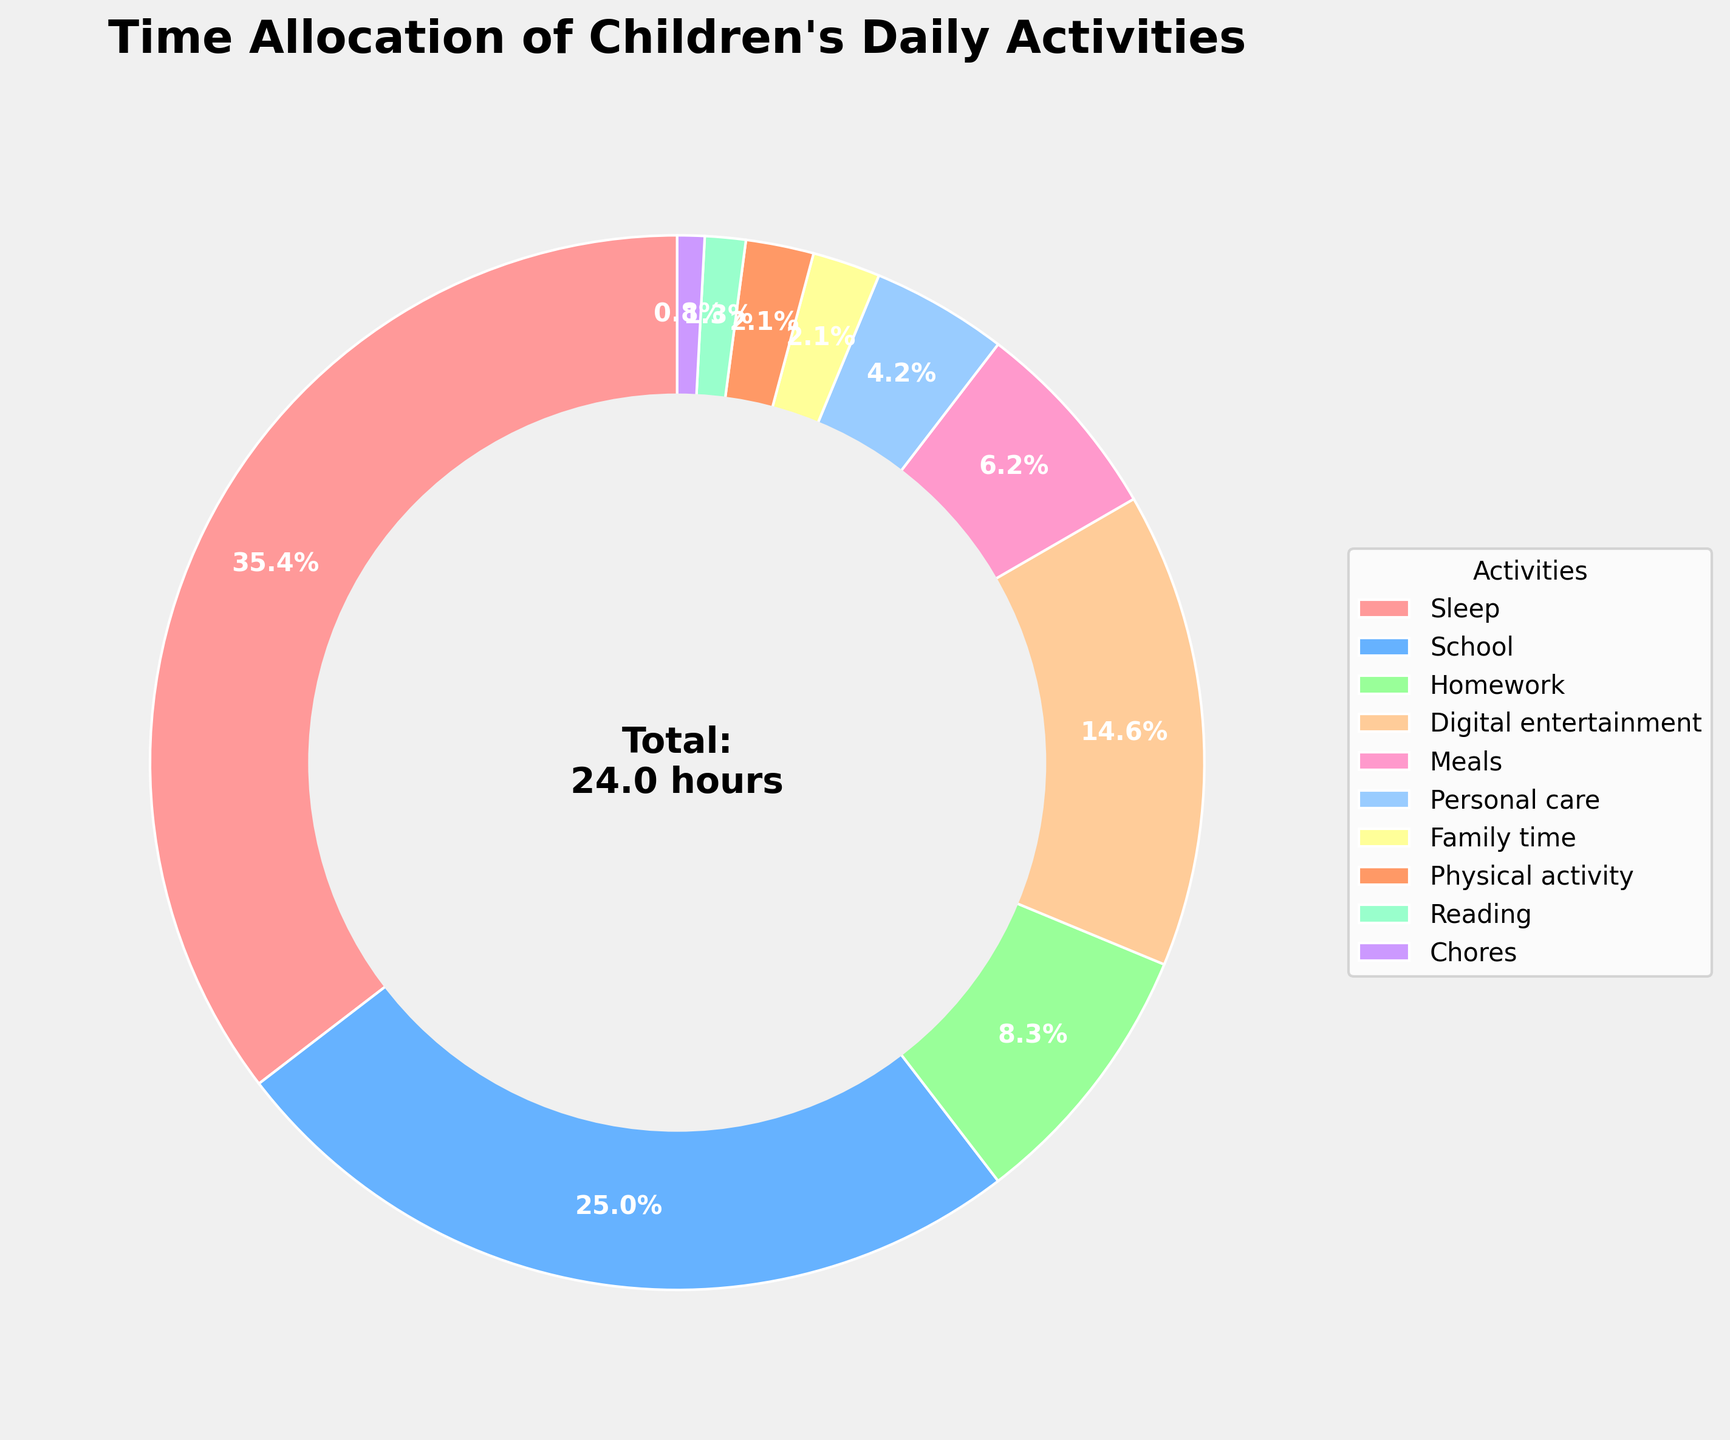How much time is spent on digital entertainment compared to school? Digital entertainment takes up 3.5 hours, and school takes 6 hours. Therefore, digital entertainment is 6 - 3.5 = 2.5 hours less than school.
Answer: 2.5 hours less Which two activities together make up the least amount of time spent? Chores and reading have the smallest amounts of time with 0.2 and 0.3 hours respectively. Their sum is 0.2 + 0.3 = 0.5 hours, which is less than any other combination.
Answer: Chores and Reading What percentage of the day is spent on sleep and school combined? Sleep takes up 8.5 hours and school takes 6 hours. Together, they make up 8.5 + 6 = 14.5 hours. The entire day totals 24 hours. Therefore, the percentage is (14.5/24) * 100 ≈ 60.4%.
Answer: 60.4% Which activity is allocated half an hour? The figure's visual cues show that family time and physical activity are both represented by half an hour since they are labeled as 0.5 hours.
Answer: Family time and Physical activity What is the difference in time spent between meals and personal care? Meals take up 1.5 hours, and personal care takes 1 hour. The difference is 1.5 - 1 = 0.5 hours.
Answer: 0.5 hours How much more time is allocated to digital entertainment than to reading? Reading gets 0.3 hours, while digital entertainment gets 3.5 hours. Therefore, digital entertainment gets 3.5 - 0.3 = 3.2 more hours than reading.
Answer: 3.2 hours If we combine the time for meals, family time, and physical activity, what part of the day do these take? Meals: 1.5 hours, Family time: 0.5 hours, Physical activity: 0.5 hours. Their total is 1.5 + 0.5 + 0.5 = 2.5 hours. They take (2.5 / 24) * 100 ≈ 10.4% of the day.
Answer: 10.4% What activities take up equal amounts of time? By reviewing the visual cues, we see that family time and physical activity both take up equal amounts of time, which is 0.5 hours each.
Answer: Family time and Physical activity 